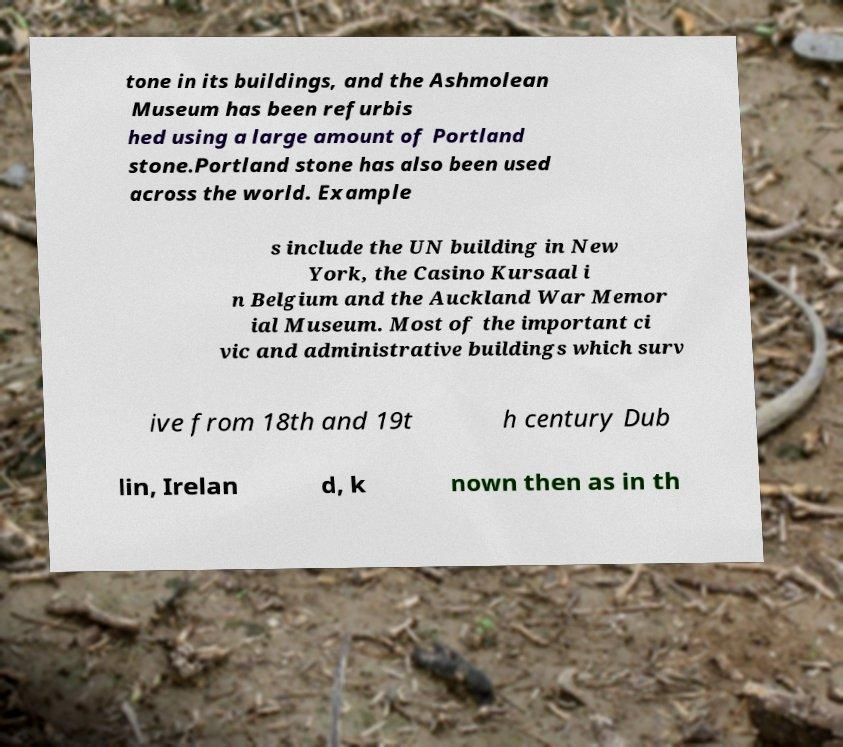I need the written content from this picture converted into text. Can you do that? tone in its buildings, and the Ashmolean Museum has been refurbis hed using a large amount of Portland stone.Portland stone has also been used across the world. Example s include the UN building in New York, the Casino Kursaal i n Belgium and the Auckland War Memor ial Museum. Most of the important ci vic and administrative buildings which surv ive from 18th and 19t h century Dub lin, Irelan d, k nown then as in th 